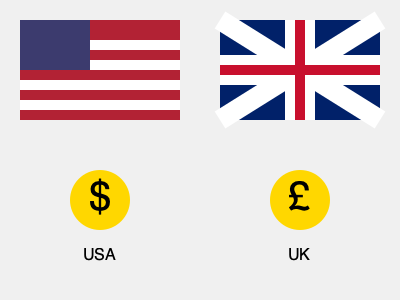Based on the visual representation of cultural differences between the USA and UK, which of the following statements is most accurate?
A) The American flag has more stripes than the British flag
B) The British pound symbol is used in both countries
C) The flags share the same primary colors
D) The American dollar symbol is larger than the British pound symbol Let's analyze the image step-by-step:

1. Flags:
   - The American flag (left) shows red and white stripes with a blue rectangle containing stars.
   - The British flag (right) displays the Union Jack with blue, white, and red colors in a different pattern.

2. Currency symbols:
   - Below the American flag, there's a gold circle with a "$" symbol.
   - Below the British flag, there's a gold circle with a "£" symbol.

3. Colors:
   - Both flags use red, white, and blue as their primary colors.

4. Size of currency symbols:
   - The "$" and "£" symbols appear to be the same size within their respective circles.

5. Stripes:
   - The American flag clearly shows multiple horizontal stripes.
   - The British flag doesn't have horizontal stripes but rather diagonal and vertical lines forming the Union Jack pattern.

Given these observations, we can evaluate each statement:

A) True, the American flag has stripes while the British flag doesn't.
B) False, each country is shown with its own distinct currency symbol.
C) True, both flags use red, white, and blue as their primary colors.
D) False, the currency symbols appear to be the same size.

The most accurate statement is C, as it correctly identifies a similarity between the two cultures represented in the image.
Answer: C) The flags share the same primary colors 